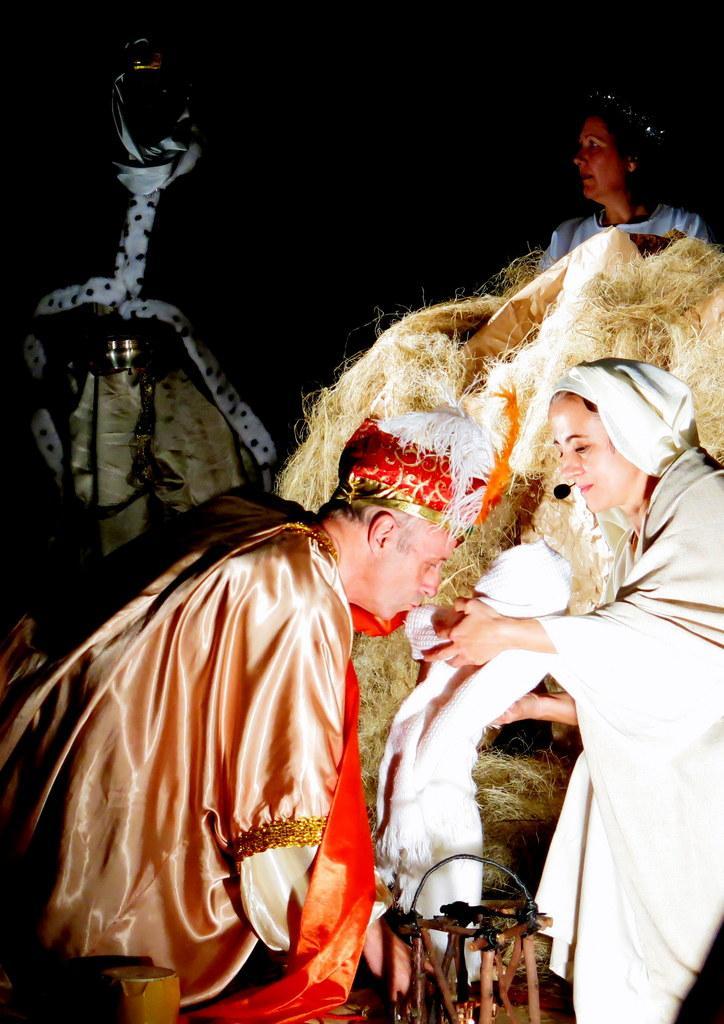How would you summarize this image in a sentence or two? In this image, we can see people wearing costumes and one of them is holding an object and we can see dry grass and at the bottom, there is a stand and some other objects. 